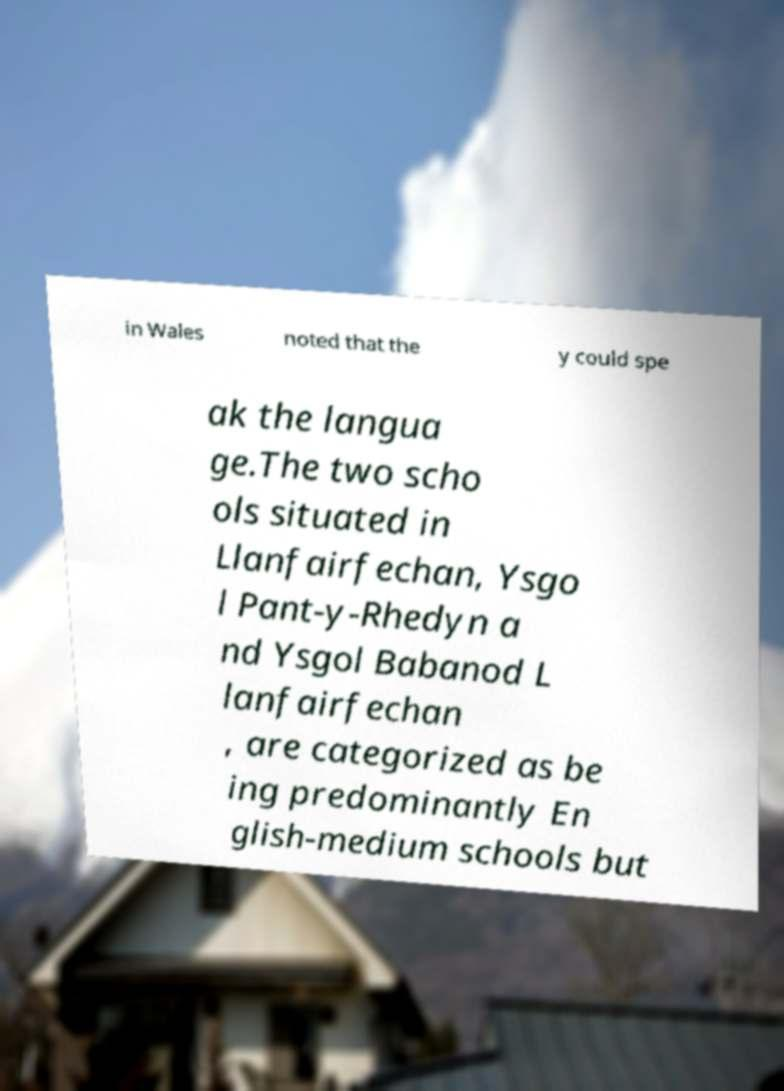What messages or text are displayed in this image? I need them in a readable, typed format. in Wales noted that the y could spe ak the langua ge.The two scho ols situated in Llanfairfechan, Ysgo l Pant-y-Rhedyn a nd Ysgol Babanod L lanfairfechan , are categorized as be ing predominantly En glish-medium schools but 